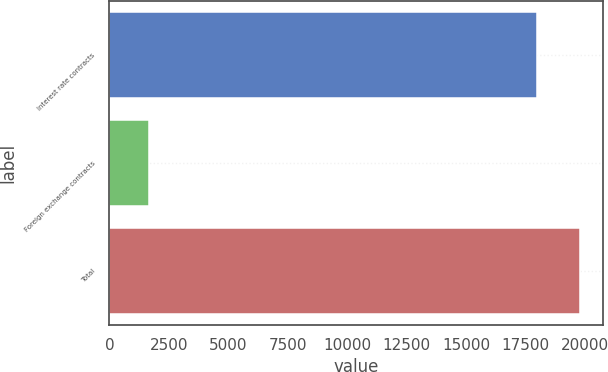Convert chart to OTSL. <chart><loc_0><loc_0><loc_500><loc_500><bar_chart><fcel>Interest rate contracts<fcel>Foreign exchange contracts<fcel>Total<nl><fcel>17964<fcel>1676<fcel>19760.4<nl></chart> 